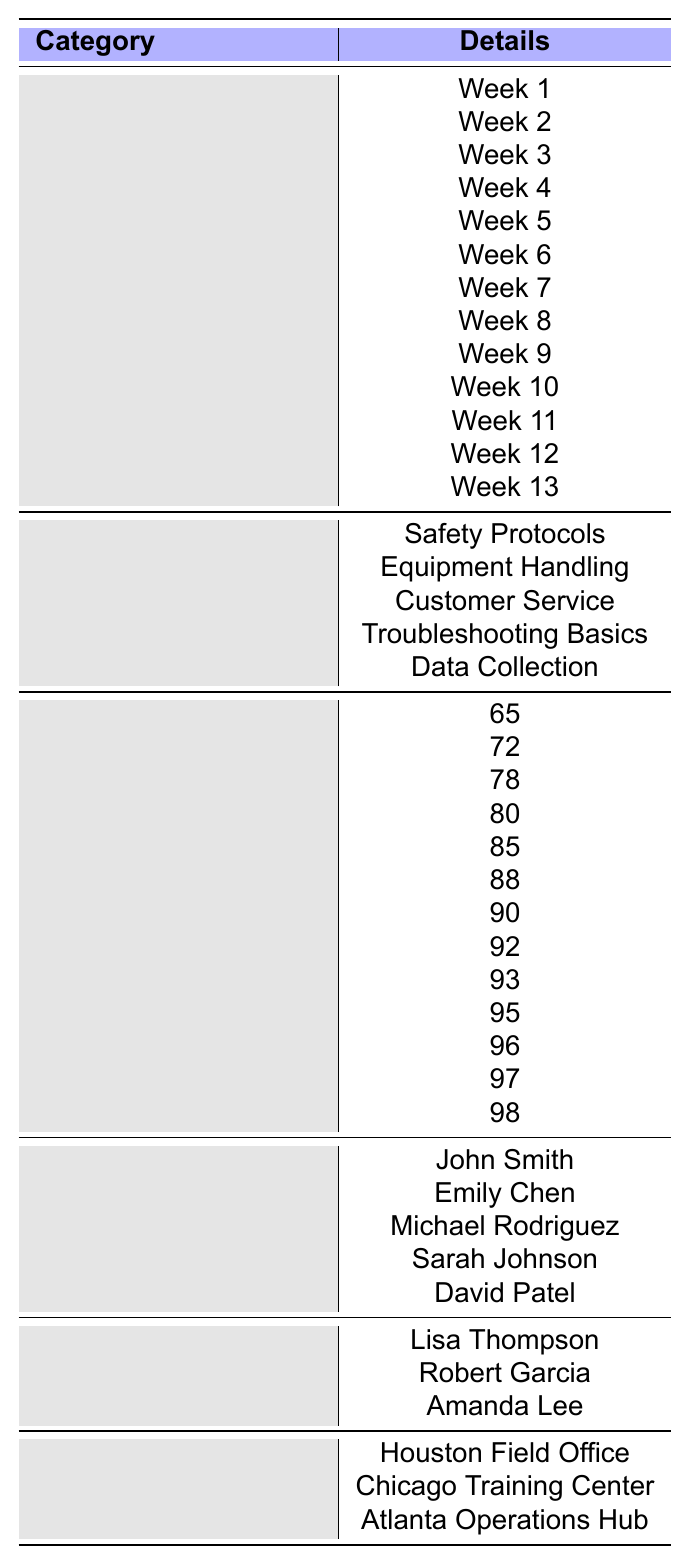What is the completion rate for Week 5? The table lists the completion rates for each week. Looking under the "Completion Rates" section aligned with "Week 5", we find the rate is 85%.
Answer: 85% How many training modules are listed? The training modules listed in the table are Safety Protocols, Equipment Handling, Customer Service, Troubleshooting Basics, and Data Collection. Counting these, we find there are 5 training modules.
Answer: 5 What was the highest completion rate recorded in the weeks? The completion rates are provided for each week. By scanning the rates, the highest completion rate is found to be 98% in Week 13.
Answer: 98% Was the completion rate for Week 8 higher than for Week 6? The completion rate for Week 8 is 92% while for Week 6 it is 88%. Since 92% > 88%, the statement is true.
Answer: Yes What is the average completion rate over the entire quarter? First, we sum the completion rates: 65 + 72 + 78 + 80 + 85 + 88 + 90 + 92 + 93 + 95 + 96 + 97 + 98 = 1077. Then, we divide by the number of weeks (13): 1077 / 13 ≈ 82.08.
Answer: 82.08 How many new technicians were trained by Amanda Lee? The table shows a list of new technicians but does not specify which trainer trained whom. Thus, we cannot determine if Amanda Lee trained any specific technician.
Answer: Unknown What was the difference in completion rates between Week 1 and Week 12? The completion rate for Week 1 is 65%, and for Week 12 it is 97%. The difference is 97 - 65 = 32%.
Answer: 32% Did any training module have a completion rate below 70%? The completion rates for all weeks start at 65% for Week 1, which is below 70%. Therefore, at least one training module does have a completion rate below that threshold.
Answer: Yes Which week had the lowest completion rate? By checking the completion rates listed for each week, we notice that Week 1 had the lowest rate of 65%.
Answer: Week 1 If the trend continues, what would be the expected completion rate for Week 14? Observing the trend from Weeks 12 (97%) to Week 13 (98%), it seems the rates are increasing by 1% each week. Therefore, the expected rate for Week 14 would be 98% + 1% = 99%.
Answer: 99% 